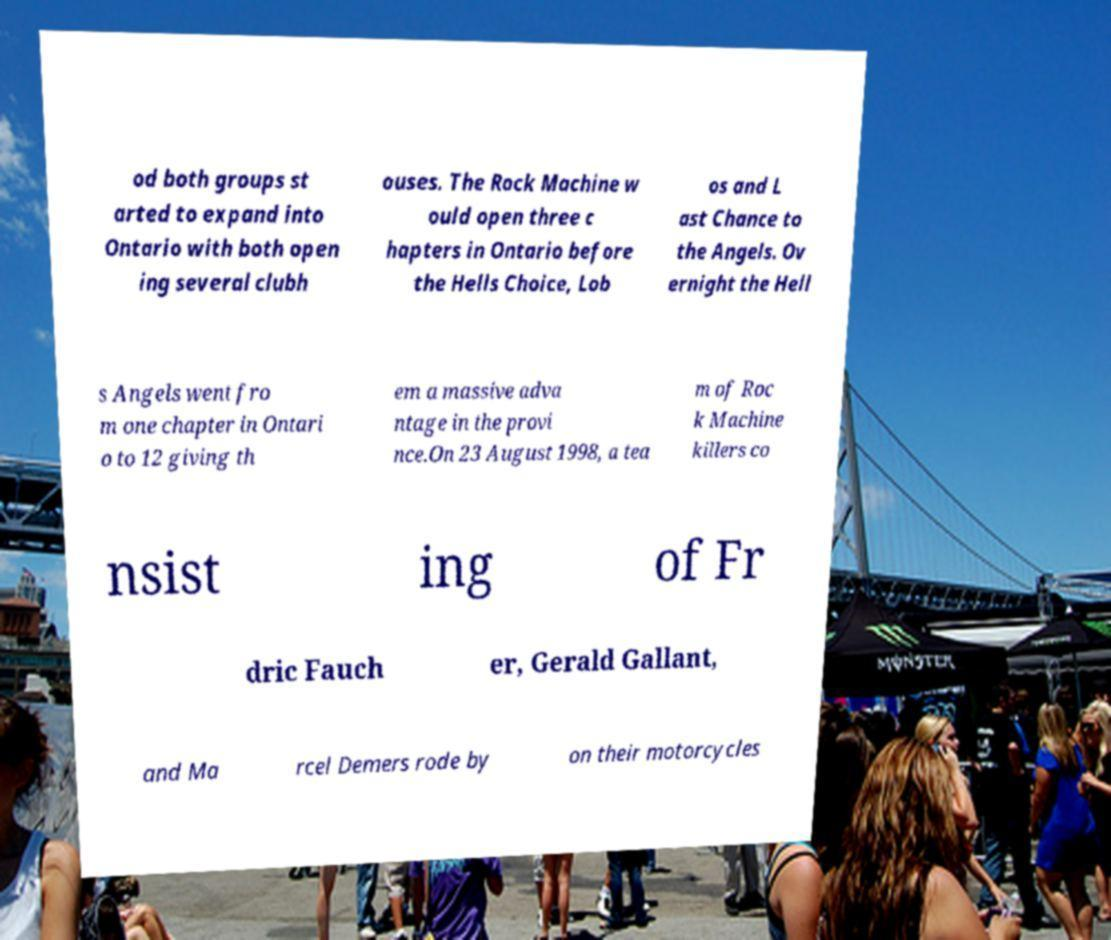There's text embedded in this image that I need extracted. Can you transcribe it verbatim? od both groups st arted to expand into Ontario with both open ing several clubh ouses. The Rock Machine w ould open three c hapters in Ontario before the Hells Choice, Lob os and L ast Chance to the Angels. Ov ernight the Hell s Angels went fro m one chapter in Ontari o to 12 giving th em a massive adva ntage in the provi nce.On 23 August 1998, a tea m of Roc k Machine killers co nsist ing of Fr dric Fauch er, Gerald Gallant, and Ma rcel Demers rode by on their motorcycles 